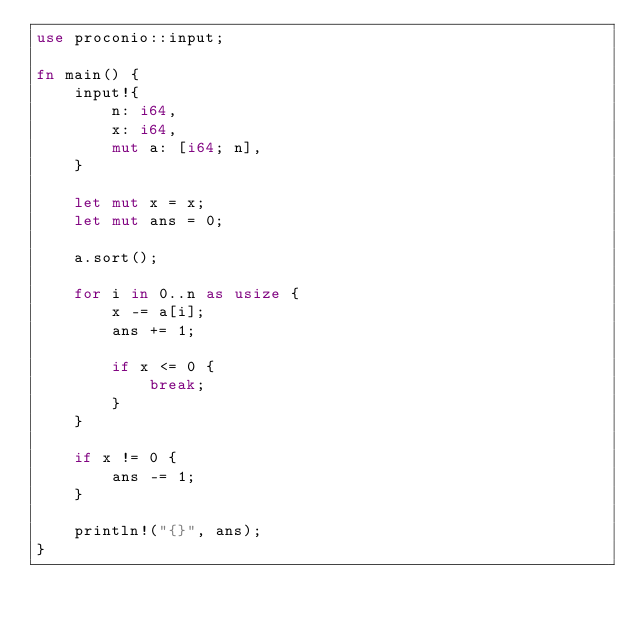Convert code to text. <code><loc_0><loc_0><loc_500><loc_500><_Rust_>use proconio::input;

fn main() {
    input!{
        n: i64,
        x: i64,
        mut a: [i64; n],
    }

    let mut x = x;
    let mut ans = 0;

    a.sort();

    for i in 0..n as usize {
        x -= a[i];
        ans += 1;

        if x <= 0 {
            break;
        }
    }

    if x != 0 {
        ans -= 1;
    }

    println!("{}", ans);
}
</code> 